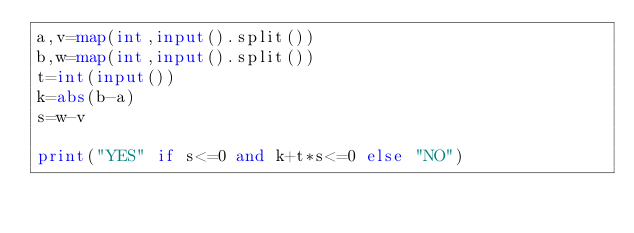Convert code to text. <code><loc_0><loc_0><loc_500><loc_500><_Python_>a,v=map(int,input().split())
b,w=map(int,input().split())
t=int(input())
k=abs(b-a)
s=w-v

print("YES" if s<=0 and k+t*s<=0 else "NO")</code> 